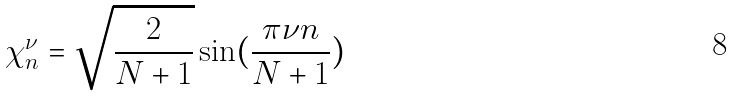Convert formula to latex. <formula><loc_0><loc_0><loc_500><loc_500>\chi _ { n } ^ { \nu } = \sqrt { \frac { 2 } { N + 1 } } \sin ( \frac { \pi \nu n } { N + 1 } )</formula> 